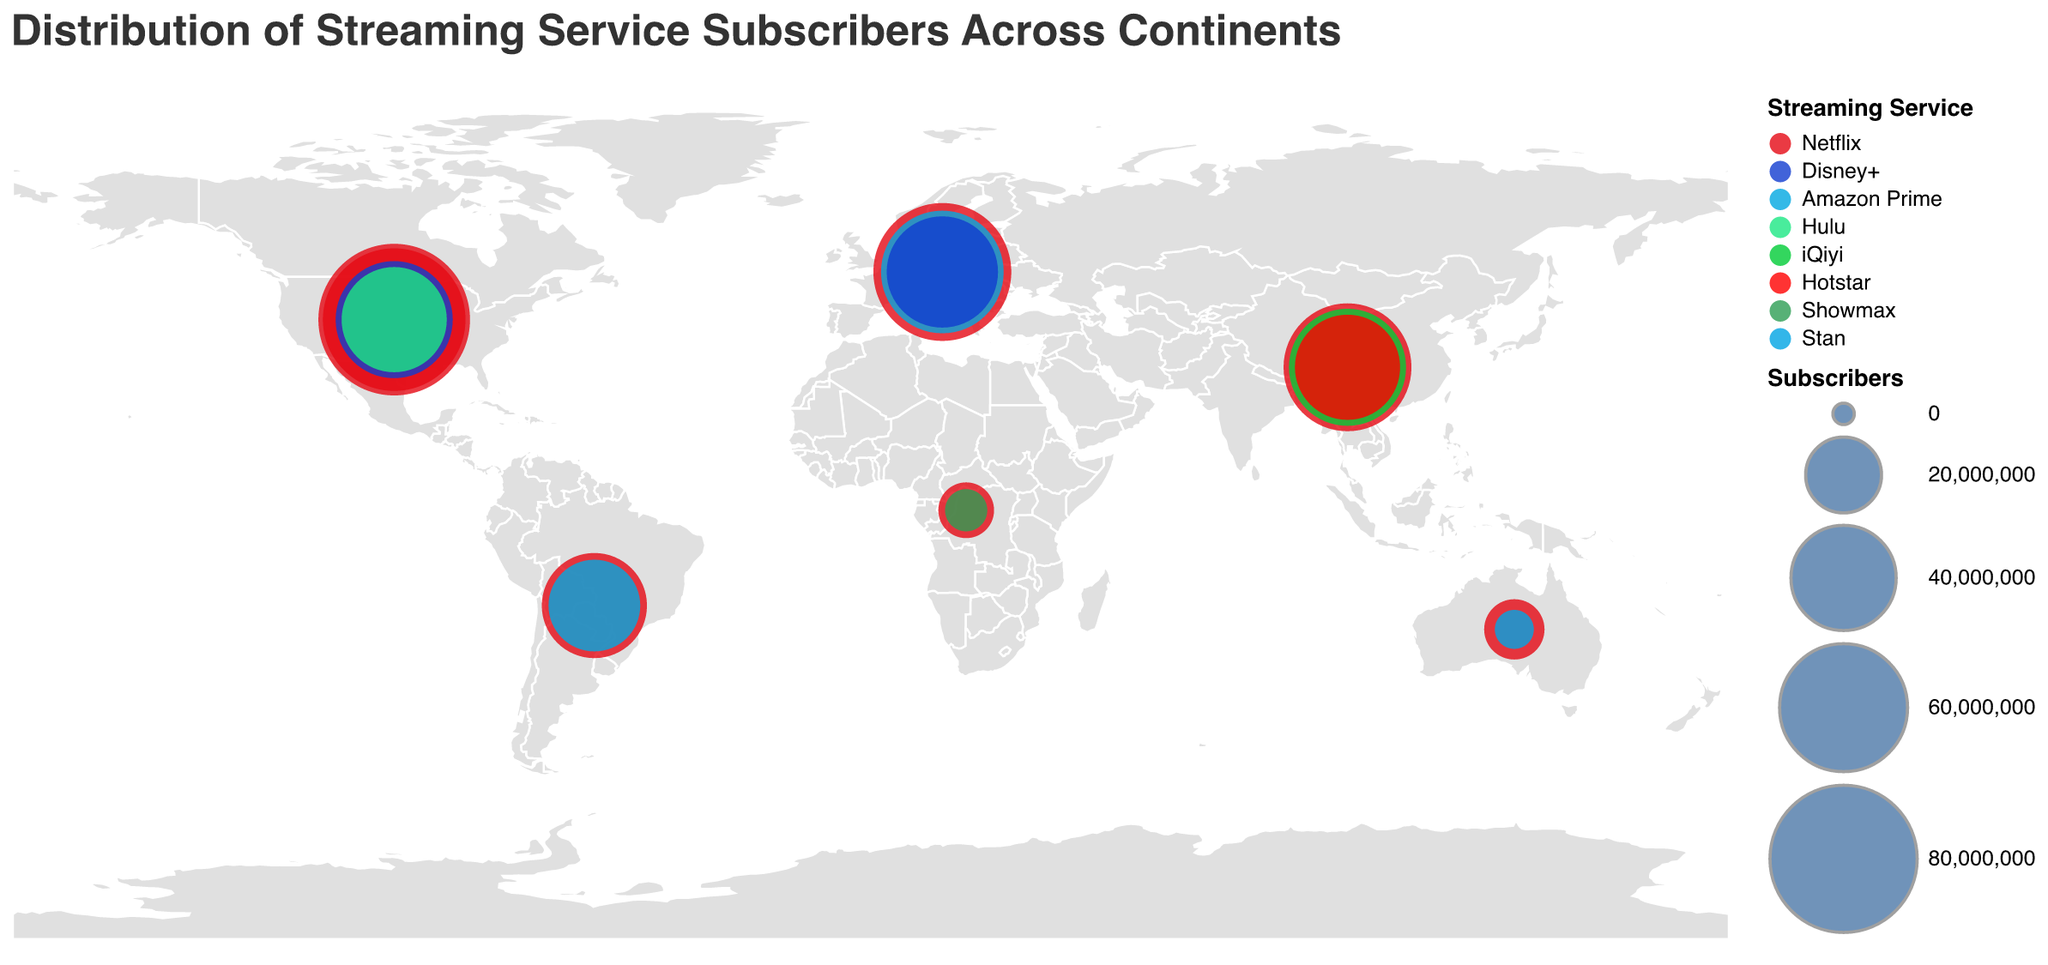Which streaming service has the most subscribers in North America? The plot highlights that Netflix has the largest circle size in North America, indicating it has the most subscribers on that continent.
Answer: Netflix In which continent does Disney+ have more subscribers: North America or Europe? By comparing the circle sizes on the map for Disney+ in North America and Europe, North America's Disney+ circle is larger than Europe's.
Answer: North America What is the total number of Netflix subscribers in Europe and Asia? In Europe and Asia, Netflix has 70,000,000 and 60,000,000 subscribers, respectively. Adding these numbers, the total is 70,000,000 + 60,000,000 = 130,000,000.
Answer: 130,000,000 Which continent has the largest number of streaming services represented? By observing the number of different colored circles (each representing a streaming service) on each continent, North America has the most with three represented services: Netflix, Disney+, and Hulu.
Answer: North America What age group has the most subscribers for Netflix in North America? By looking at the tooltip information for Netflix in North America, the 18-34 age group has 85,000,000 subscribers compared to 75,000,000 for the 35-54 age group.
Answer: 18-34 Which gender has more subscribers for Netflix in the dataset? By summing up Netflix subscribers from all entries: Female (85,000,000 in North America + 70,000,000 in Europe + 60,000,000 in Asia + 40,000,000 in South America + 10,000,000 in Africa + 12,000,000 in Oceania) and Male (75,000,000 in North America). Females total = 277,000,000; Males total = 75,000,000.
Answer: Female What's the difference in the number of Netflix subscribers between North America and South America? Netflix has 85,000,000 (Female) + 75,000,000 (Male) = 160,000,000 subscribers in North America and 40,000,000 subscribers in South America. The difference is 160,000,000 - 40,000,000 = 120,000,000.
Answer: 120,000,000 Which streaming service has the least subscribers in the dataset? By examining the smallest circle sizes, Stan in Oceania has 4,000,000 subscribers, which is the smallest number in the dataset.
Answer: Stan 